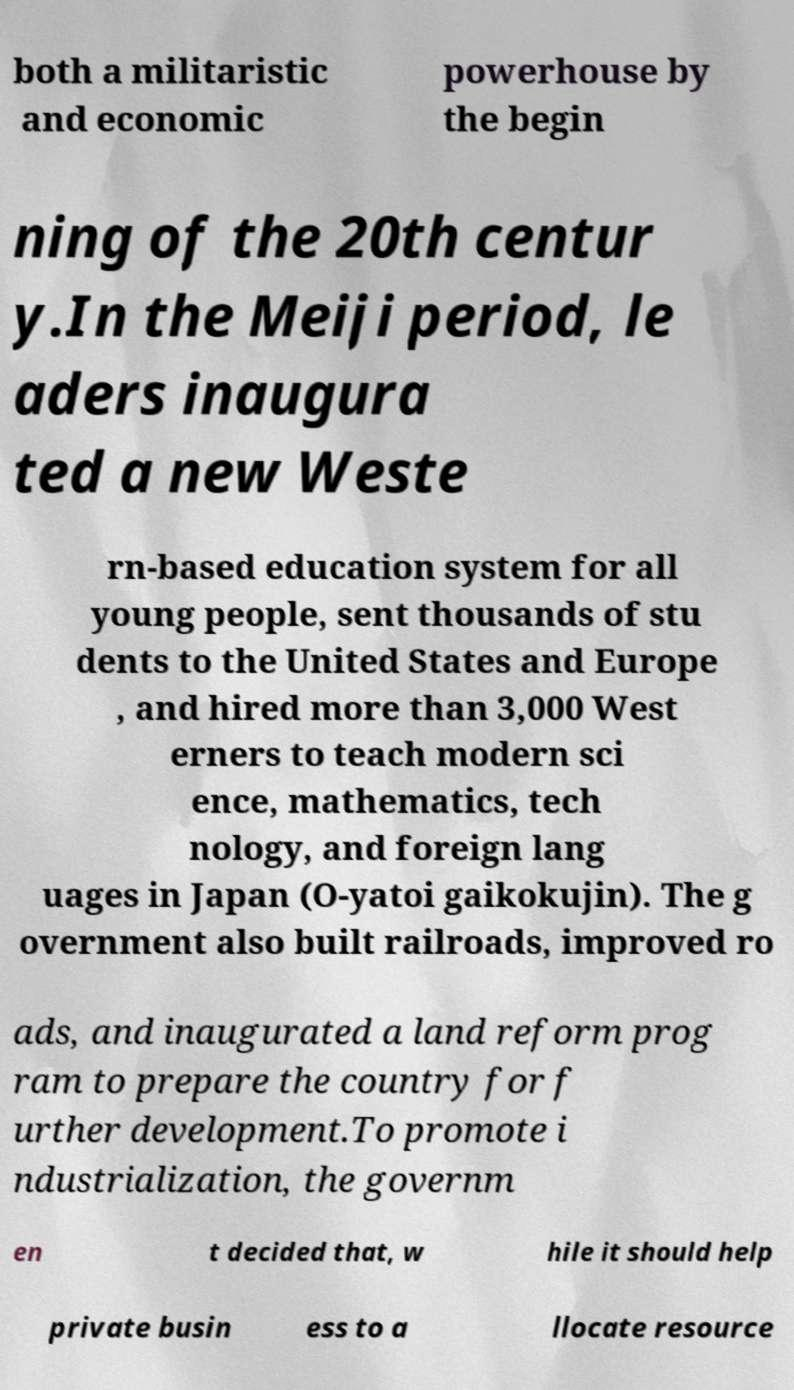Please read and relay the text visible in this image. What does it say? both a militaristic and economic powerhouse by the begin ning of the 20th centur y.In the Meiji period, le aders inaugura ted a new Weste rn-based education system for all young people, sent thousands of stu dents to the United States and Europe , and hired more than 3,000 West erners to teach modern sci ence, mathematics, tech nology, and foreign lang uages in Japan (O-yatoi gaikokujin). The g overnment also built railroads, improved ro ads, and inaugurated a land reform prog ram to prepare the country for f urther development.To promote i ndustrialization, the governm en t decided that, w hile it should help private busin ess to a llocate resource 